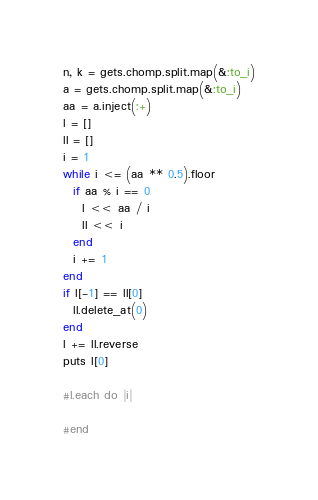Convert code to text. <code><loc_0><loc_0><loc_500><loc_500><_Ruby_>n, k = gets.chomp.split.map(&:to_i)
a = gets.chomp.split.map(&:to_i)
aa = a.inject(:+)
l = []
ll = []
i = 1
while i <= (aa ** 0.5).floor
  if aa % i == 0
    l << aa / i
    ll << i
  end
  i += 1
end
if l[-1] == ll[0]
  ll.delete_at(0)
end
l += ll.reverse
puts l[0]

#l.each do |i|
  
#end

</code> 